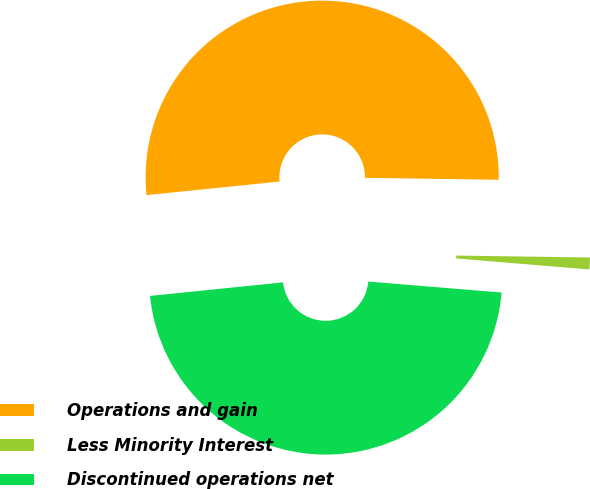Convert chart to OTSL. <chart><loc_0><loc_0><loc_500><loc_500><pie_chart><fcel>Operations and gain<fcel>Less Minority Interest<fcel>Discontinued operations net<nl><fcel>51.85%<fcel>1.08%<fcel>47.07%<nl></chart> 